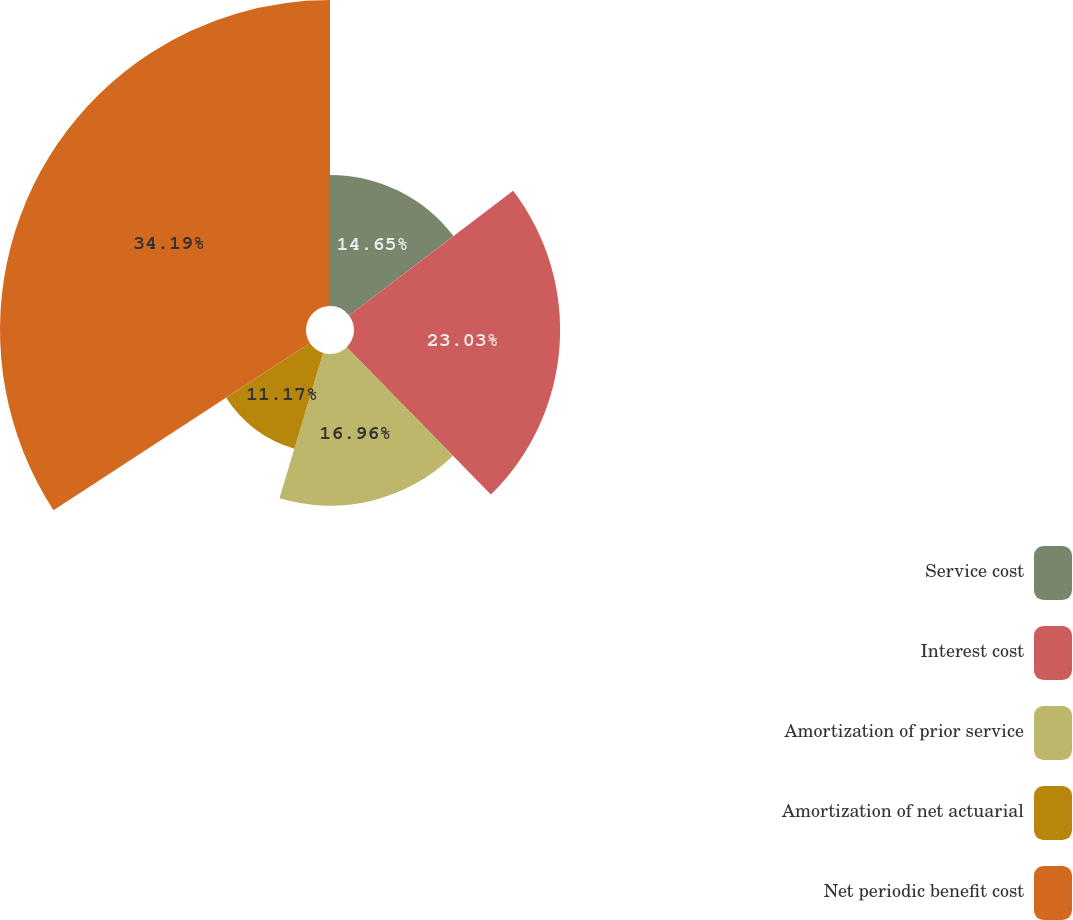<chart> <loc_0><loc_0><loc_500><loc_500><pie_chart><fcel>Service cost<fcel>Interest cost<fcel>Amortization of prior service<fcel>Amortization of net actuarial<fcel>Net periodic benefit cost<nl><fcel>14.65%<fcel>23.03%<fcel>16.96%<fcel>11.17%<fcel>34.19%<nl></chart> 